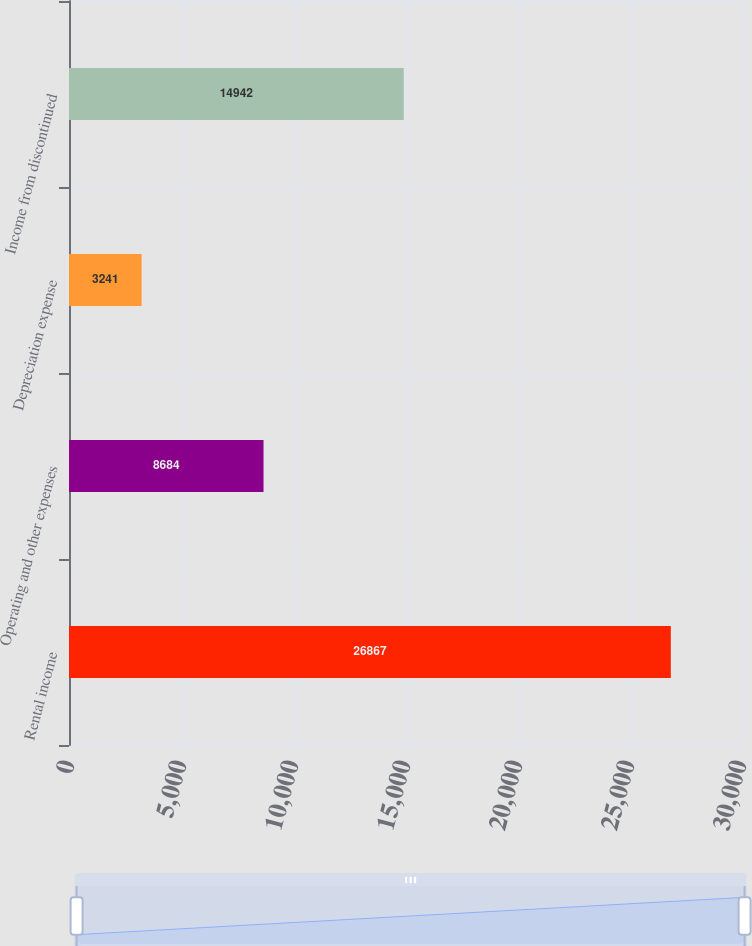Convert chart to OTSL. <chart><loc_0><loc_0><loc_500><loc_500><bar_chart><fcel>Rental income<fcel>Operating and other expenses<fcel>Depreciation expense<fcel>Income from discontinued<nl><fcel>26867<fcel>8684<fcel>3241<fcel>14942<nl></chart> 